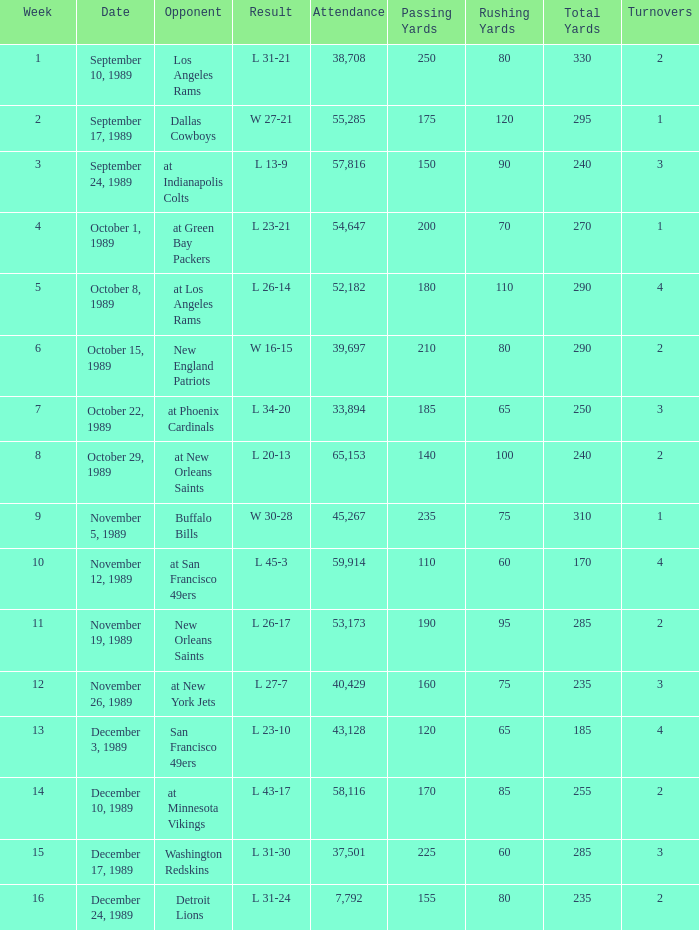For what week was the attendance 40,429? 12.0. 